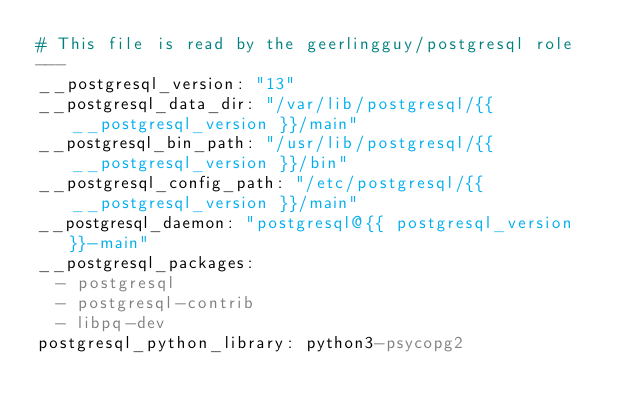Convert code to text. <code><loc_0><loc_0><loc_500><loc_500><_YAML_># This file is read by the geerlingguy/postgresql role
---
__postgresql_version: "13"
__postgresql_data_dir: "/var/lib/postgresql/{{ __postgresql_version }}/main"
__postgresql_bin_path: "/usr/lib/postgresql/{{ __postgresql_version }}/bin"
__postgresql_config_path: "/etc/postgresql/{{ __postgresql_version }}/main"
__postgresql_daemon: "postgresql@{{ postgresql_version }}-main"
__postgresql_packages:
  - postgresql
  - postgresql-contrib
  - libpq-dev
postgresql_python_library: python3-psycopg2
</code> 